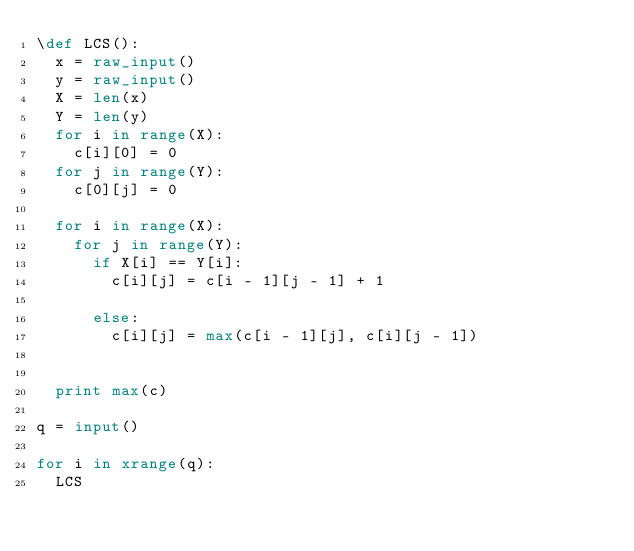Convert code to text. <code><loc_0><loc_0><loc_500><loc_500><_Python_>\def LCS():
  x = raw_input()
  y = raw_input()
  X = len(x)
  Y = len(y)
  for i in range(X):
    c[i][0] = 0
  for j in range(Y):
    c[0][j] = 0
 
  for i in range(X):
    for j in range(Y):
      if X[i] == Y[i]: 
        c[i][j] = c[i - 1][j - 1] + 1
 
      else:
        c[i][j] = max(c[i - 1][j], c[i][j - 1])
         
 
  print max(c)
 
q = input()
 
for i in xrange(q):
  LCS</code> 